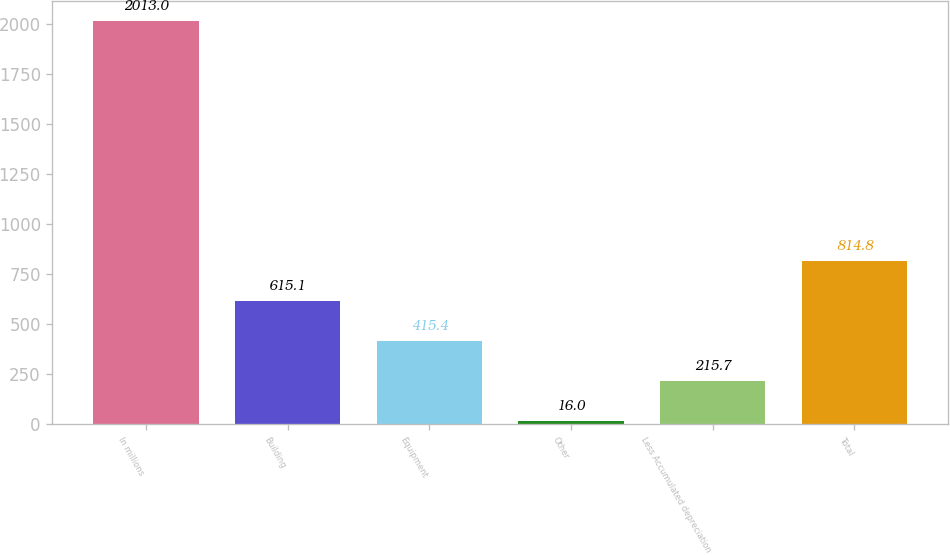Convert chart to OTSL. <chart><loc_0><loc_0><loc_500><loc_500><bar_chart><fcel>In millions<fcel>Building<fcel>Equipment<fcel>Other<fcel>Less Accumulated depreciation<fcel>Total<nl><fcel>2013<fcel>615.1<fcel>415.4<fcel>16<fcel>215.7<fcel>814.8<nl></chart> 